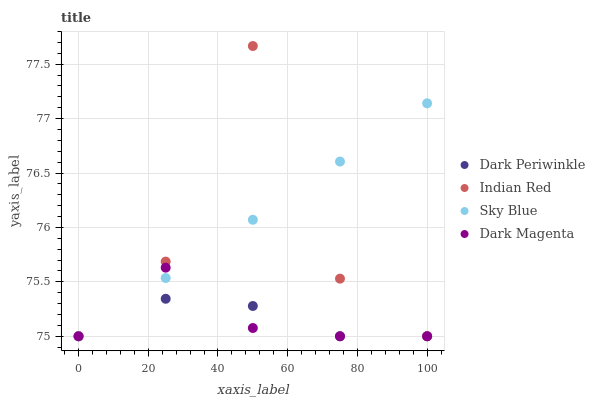Does Dark Periwinkle have the minimum area under the curve?
Answer yes or no. Yes. Does Sky Blue have the maximum area under the curve?
Answer yes or no. Yes. Does Indian Red have the minimum area under the curve?
Answer yes or no. No. Does Indian Red have the maximum area under the curve?
Answer yes or no. No. Is Sky Blue the smoothest?
Answer yes or no. Yes. Is Indian Red the roughest?
Answer yes or no. Yes. Is Dark Periwinkle the smoothest?
Answer yes or no. No. Is Dark Periwinkle the roughest?
Answer yes or no. No. Does Sky Blue have the lowest value?
Answer yes or no. Yes. Does Indian Red have the highest value?
Answer yes or no. Yes. Does Dark Periwinkle have the highest value?
Answer yes or no. No. Does Indian Red intersect Dark Periwinkle?
Answer yes or no. Yes. Is Indian Red less than Dark Periwinkle?
Answer yes or no. No. Is Indian Red greater than Dark Periwinkle?
Answer yes or no. No. 